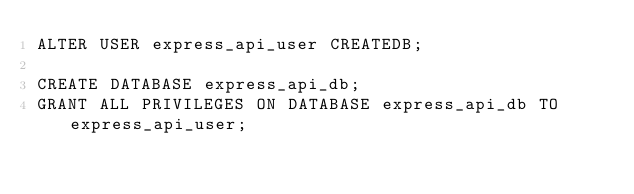Convert code to text. <code><loc_0><loc_0><loc_500><loc_500><_SQL_>ALTER USER express_api_user CREATEDB;

CREATE DATABASE express_api_db;
GRANT ALL PRIVILEGES ON DATABASE express_api_db TO express_api_user;</code> 